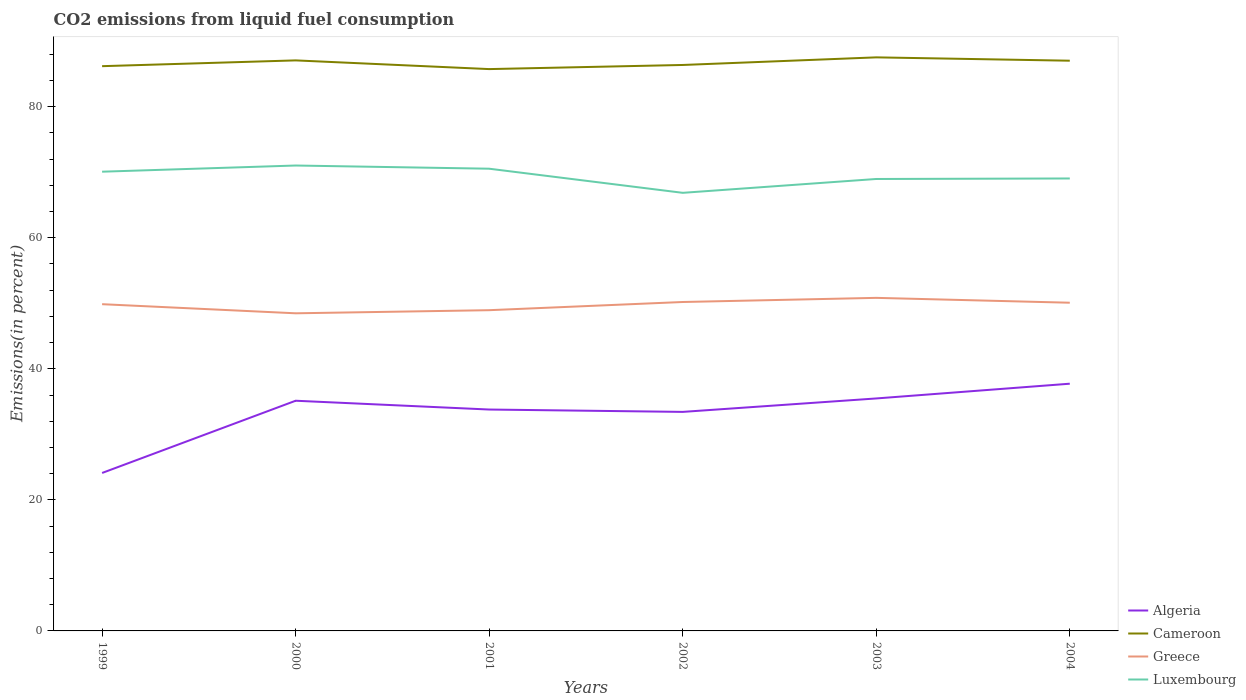How many different coloured lines are there?
Your answer should be very brief. 4. Is the number of lines equal to the number of legend labels?
Provide a succinct answer. Yes. Across all years, what is the maximum total CO2 emitted in Luxembourg?
Give a very brief answer. 66.86. In which year was the total CO2 emitted in Algeria maximum?
Offer a terse response. 1999. What is the total total CO2 emitted in Greece in the graph?
Offer a terse response. -2.36. What is the difference between the highest and the second highest total CO2 emitted in Greece?
Provide a short and direct response. 2.36. What is the difference between the highest and the lowest total CO2 emitted in Cameroon?
Your answer should be very brief. 3. How many years are there in the graph?
Ensure brevity in your answer.  6. What is the difference between two consecutive major ticks on the Y-axis?
Offer a very short reply. 20. Are the values on the major ticks of Y-axis written in scientific E-notation?
Offer a terse response. No. Does the graph contain grids?
Offer a terse response. No. What is the title of the graph?
Ensure brevity in your answer.  CO2 emissions from liquid fuel consumption. What is the label or title of the X-axis?
Keep it short and to the point. Years. What is the label or title of the Y-axis?
Provide a short and direct response. Emissions(in percent). What is the Emissions(in percent) in Algeria in 1999?
Give a very brief answer. 24.11. What is the Emissions(in percent) in Cameroon in 1999?
Make the answer very short. 86.19. What is the Emissions(in percent) of Greece in 1999?
Make the answer very short. 49.86. What is the Emissions(in percent) of Luxembourg in 1999?
Provide a succinct answer. 70.09. What is the Emissions(in percent) in Algeria in 2000?
Your answer should be compact. 35.13. What is the Emissions(in percent) of Cameroon in 2000?
Offer a terse response. 87.07. What is the Emissions(in percent) in Greece in 2000?
Your response must be concise. 48.48. What is the Emissions(in percent) of Luxembourg in 2000?
Make the answer very short. 71.03. What is the Emissions(in percent) in Algeria in 2001?
Keep it short and to the point. 33.79. What is the Emissions(in percent) in Cameroon in 2001?
Make the answer very short. 85.74. What is the Emissions(in percent) in Greece in 2001?
Make the answer very short. 48.95. What is the Emissions(in percent) of Luxembourg in 2001?
Provide a short and direct response. 70.54. What is the Emissions(in percent) in Algeria in 2002?
Keep it short and to the point. 33.43. What is the Emissions(in percent) of Cameroon in 2002?
Your answer should be very brief. 86.37. What is the Emissions(in percent) in Greece in 2002?
Your answer should be very brief. 50.2. What is the Emissions(in percent) of Luxembourg in 2002?
Offer a very short reply. 66.86. What is the Emissions(in percent) in Algeria in 2003?
Offer a terse response. 35.48. What is the Emissions(in percent) in Cameroon in 2003?
Keep it short and to the point. 87.54. What is the Emissions(in percent) in Greece in 2003?
Your answer should be very brief. 50.83. What is the Emissions(in percent) of Luxembourg in 2003?
Offer a very short reply. 68.97. What is the Emissions(in percent) of Algeria in 2004?
Keep it short and to the point. 37.73. What is the Emissions(in percent) of Cameroon in 2004?
Provide a short and direct response. 87.03. What is the Emissions(in percent) of Greece in 2004?
Ensure brevity in your answer.  50.09. What is the Emissions(in percent) of Luxembourg in 2004?
Ensure brevity in your answer.  69.05. Across all years, what is the maximum Emissions(in percent) of Algeria?
Your answer should be very brief. 37.73. Across all years, what is the maximum Emissions(in percent) of Cameroon?
Your answer should be very brief. 87.54. Across all years, what is the maximum Emissions(in percent) of Greece?
Your answer should be compact. 50.83. Across all years, what is the maximum Emissions(in percent) in Luxembourg?
Make the answer very short. 71.03. Across all years, what is the minimum Emissions(in percent) in Algeria?
Your answer should be very brief. 24.11. Across all years, what is the minimum Emissions(in percent) of Cameroon?
Your answer should be compact. 85.74. Across all years, what is the minimum Emissions(in percent) of Greece?
Your answer should be compact. 48.48. Across all years, what is the minimum Emissions(in percent) of Luxembourg?
Offer a very short reply. 66.86. What is the total Emissions(in percent) of Algeria in the graph?
Keep it short and to the point. 199.66. What is the total Emissions(in percent) in Cameroon in the graph?
Your response must be concise. 519.94. What is the total Emissions(in percent) of Greece in the graph?
Offer a very short reply. 298.41. What is the total Emissions(in percent) of Luxembourg in the graph?
Ensure brevity in your answer.  416.54. What is the difference between the Emissions(in percent) in Algeria in 1999 and that in 2000?
Keep it short and to the point. -11.02. What is the difference between the Emissions(in percent) of Cameroon in 1999 and that in 2000?
Your response must be concise. -0.88. What is the difference between the Emissions(in percent) of Greece in 1999 and that in 2000?
Provide a succinct answer. 1.39. What is the difference between the Emissions(in percent) of Luxembourg in 1999 and that in 2000?
Offer a terse response. -0.94. What is the difference between the Emissions(in percent) in Algeria in 1999 and that in 2001?
Give a very brief answer. -9.68. What is the difference between the Emissions(in percent) in Cameroon in 1999 and that in 2001?
Keep it short and to the point. 0.45. What is the difference between the Emissions(in percent) in Greece in 1999 and that in 2001?
Your response must be concise. 0.91. What is the difference between the Emissions(in percent) in Luxembourg in 1999 and that in 2001?
Provide a short and direct response. -0.46. What is the difference between the Emissions(in percent) of Algeria in 1999 and that in 2002?
Offer a very short reply. -9.32. What is the difference between the Emissions(in percent) of Cameroon in 1999 and that in 2002?
Provide a short and direct response. -0.18. What is the difference between the Emissions(in percent) in Greece in 1999 and that in 2002?
Offer a terse response. -0.34. What is the difference between the Emissions(in percent) of Luxembourg in 1999 and that in 2002?
Provide a short and direct response. 3.22. What is the difference between the Emissions(in percent) of Algeria in 1999 and that in 2003?
Provide a succinct answer. -11.37. What is the difference between the Emissions(in percent) of Cameroon in 1999 and that in 2003?
Make the answer very short. -1.35. What is the difference between the Emissions(in percent) of Greece in 1999 and that in 2003?
Provide a succinct answer. -0.97. What is the difference between the Emissions(in percent) in Luxembourg in 1999 and that in 2003?
Provide a succinct answer. 1.11. What is the difference between the Emissions(in percent) of Algeria in 1999 and that in 2004?
Keep it short and to the point. -13.62. What is the difference between the Emissions(in percent) in Cameroon in 1999 and that in 2004?
Make the answer very short. -0.83. What is the difference between the Emissions(in percent) of Greece in 1999 and that in 2004?
Provide a short and direct response. -0.22. What is the difference between the Emissions(in percent) of Luxembourg in 1999 and that in 2004?
Your answer should be very brief. 1.03. What is the difference between the Emissions(in percent) of Algeria in 2000 and that in 2001?
Your response must be concise. 1.34. What is the difference between the Emissions(in percent) in Cameroon in 2000 and that in 2001?
Your answer should be compact. 1.33. What is the difference between the Emissions(in percent) of Greece in 2000 and that in 2001?
Your answer should be compact. -0.48. What is the difference between the Emissions(in percent) in Luxembourg in 2000 and that in 2001?
Keep it short and to the point. 0.49. What is the difference between the Emissions(in percent) of Algeria in 2000 and that in 2002?
Keep it short and to the point. 1.7. What is the difference between the Emissions(in percent) of Cameroon in 2000 and that in 2002?
Provide a short and direct response. 0.7. What is the difference between the Emissions(in percent) of Greece in 2000 and that in 2002?
Provide a succinct answer. -1.72. What is the difference between the Emissions(in percent) in Luxembourg in 2000 and that in 2002?
Ensure brevity in your answer.  4.17. What is the difference between the Emissions(in percent) in Algeria in 2000 and that in 2003?
Keep it short and to the point. -0.35. What is the difference between the Emissions(in percent) of Cameroon in 2000 and that in 2003?
Offer a terse response. -0.46. What is the difference between the Emissions(in percent) in Greece in 2000 and that in 2003?
Ensure brevity in your answer.  -2.36. What is the difference between the Emissions(in percent) in Luxembourg in 2000 and that in 2003?
Your answer should be very brief. 2.05. What is the difference between the Emissions(in percent) in Algeria in 2000 and that in 2004?
Give a very brief answer. -2.6. What is the difference between the Emissions(in percent) of Cameroon in 2000 and that in 2004?
Your answer should be compact. 0.05. What is the difference between the Emissions(in percent) of Greece in 2000 and that in 2004?
Your response must be concise. -1.61. What is the difference between the Emissions(in percent) of Luxembourg in 2000 and that in 2004?
Provide a succinct answer. 1.98. What is the difference between the Emissions(in percent) in Algeria in 2001 and that in 2002?
Keep it short and to the point. 0.36. What is the difference between the Emissions(in percent) of Cameroon in 2001 and that in 2002?
Provide a short and direct response. -0.63. What is the difference between the Emissions(in percent) in Greece in 2001 and that in 2002?
Offer a very short reply. -1.25. What is the difference between the Emissions(in percent) in Luxembourg in 2001 and that in 2002?
Provide a succinct answer. 3.68. What is the difference between the Emissions(in percent) of Algeria in 2001 and that in 2003?
Ensure brevity in your answer.  -1.69. What is the difference between the Emissions(in percent) of Cameroon in 2001 and that in 2003?
Provide a short and direct response. -1.79. What is the difference between the Emissions(in percent) in Greece in 2001 and that in 2003?
Make the answer very short. -1.88. What is the difference between the Emissions(in percent) of Luxembourg in 2001 and that in 2003?
Ensure brevity in your answer.  1.57. What is the difference between the Emissions(in percent) in Algeria in 2001 and that in 2004?
Offer a terse response. -3.94. What is the difference between the Emissions(in percent) in Cameroon in 2001 and that in 2004?
Ensure brevity in your answer.  -1.28. What is the difference between the Emissions(in percent) in Greece in 2001 and that in 2004?
Keep it short and to the point. -1.14. What is the difference between the Emissions(in percent) in Luxembourg in 2001 and that in 2004?
Provide a short and direct response. 1.49. What is the difference between the Emissions(in percent) in Algeria in 2002 and that in 2003?
Ensure brevity in your answer.  -2.05. What is the difference between the Emissions(in percent) of Cameroon in 2002 and that in 2003?
Provide a short and direct response. -1.16. What is the difference between the Emissions(in percent) of Greece in 2002 and that in 2003?
Your response must be concise. -0.63. What is the difference between the Emissions(in percent) of Luxembourg in 2002 and that in 2003?
Your answer should be compact. -2.11. What is the difference between the Emissions(in percent) in Algeria in 2002 and that in 2004?
Offer a terse response. -4.3. What is the difference between the Emissions(in percent) in Cameroon in 2002 and that in 2004?
Keep it short and to the point. -0.65. What is the difference between the Emissions(in percent) of Greece in 2002 and that in 2004?
Offer a terse response. 0.11. What is the difference between the Emissions(in percent) of Luxembourg in 2002 and that in 2004?
Offer a very short reply. -2.19. What is the difference between the Emissions(in percent) of Algeria in 2003 and that in 2004?
Offer a terse response. -2.25. What is the difference between the Emissions(in percent) of Cameroon in 2003 and that in 2004?
Your response must be concise. 0.51. What is the difference between the Emissions(in percent) in Greece in 2003 and that in 2004?
Offer a very short reply. 0.74. What is the difference between the Emissions(in percent) in Luxembourg in 2003 and that in 2004?
Your answer should be very brief. -0.08. What is the difference between the Emissions(in percent) in Algeria in 1999 and the Emissions(in percent) in Cameroon in 2000?
Keep it short and to the point. -62.97. What is the difference between the Emissions(in percent) of Algeria in 1999 and the Emissions(in percent) of Greece in 2000?
Your answer should be compact. -24.37. What is the difference between the Emissions(in percent) in Algeria in 1999 and the Emissions(in percent) in Luxembourg in 2000?
Your response must be concise. -46.92. What is the difference between the Emissions(in percent) in Cameroon in 1999 and the Emissions(in percent) in Greece in 2000?
Keep it short and to the point. 37.72. What is the difference between the Emissions(in percent) in Cameroon in 1999 and the Emissions(in percent) in Luxembourg in 2000?
Your answer should be very brief. 15.16. What is the difference between the Emissions(in percent) in Greece in 1999 and the Emissions(in percent) in Luxembourg in 2000?
Provide a short and direct response. -21.16. What is the difference between the Emissions(in percent) in Algeria in 1999 and the Emissions(in percent) in Cameroon in 2001?
Your response must be concise. -61.64. What is the difference between the Emissions(in percent) in Algeria in 1999 and the Emissions(in percent) in Greece in 2001?
Offer a very short reply. -24.84. What is the difference between the Emissions(in percent) of Algeria in 1999 and the Emissions(in percent) of Luxembourg in 2001?
Provide a succinct answer. -46.43. What is the difference between the Emissions(in percent) in Cameroon in 1999 and the Emissions(in percent) in Greece in 2001?
Offer a very short reply. 37.24. What is the difference between the Emissions(in percent) of Cameroon in 1999 and the Emissions(in percent) of Luxembourg in 2001?
Offer a very short reply. 15.65. What is the difference between the Emissions(in percent) in Greece in 1999 and the Emissions(in percent) in Luxembourg in 2001?
Your answer should be very brief. -20.68. What is the difference between the Emissions(in percent) of Algeria in 1999 and the Emissions(in percent) of Cameroon in 2002?
Provide a short and direct response. -62.27. What is the difference between the Emissions(in percent) of Algeria in 1999 and the Emissions(in percent) of Greece in 2002?
Ensure brevity in your answer.  -26.09. What is the difference between the Emissions(in percent) of Algeria in 1999 and the Emissions(in percent) of Luxembourg in 2002?
Ensure brevity in your answer.  -42.75. What is the difference between the Emissions(in percent) in Cameroon in 1999 and the Emissions(in percent) in Greece in 2002?
Offer a terse response. 35.99. What is the difference between the Emissions(in percent) of Cameroon in 1999 and the Emissions(in percent) of Luxembourg in 2002?
Offer a terse response. 19.33. What is the difference between the Emissions(in percent) in Greece in 1999 and the Emissions(in percent) in Luxembourg in 2002?
Provide a succinct answer. -17. What is the difference between the Emissions(in percent) of Algeria in 1999 and the Emissions(in percent) of Cameroon in 2003?
Your answer should be very brief. -63.43. What is the difference between the Emissions(in percent) of Algeria in 1999 and the Emissions(in percent) of Greece in 2003?
Provide a short and direct response. -26.72. What is the difference between the Emissions(in percent) in Algeria in 1999 and the Emissions(in percent) in Luxembourg in 2003?
Keep it short and to the point. -44.87. What is the difference between the Emissions(in percent) in Cameroon in 1999 and the Emissions(in percent) in Greece in 2003?
Your answer should be compact. 35.36. What is the difference between the Emissions(in percent) in Cameroon in 1999 and the Emissions(in percent) in Luxembourg in 2003?
Offer a very short reply. 17.22. What is the difference between the Emissions(in percent) of Greece in 1999 and the Emissions(in percent) of Luxembourg in 2003?
Your answer should be compact. -19.11. What is the difference between the Emissions(in percent) of Algeria in 1999 and the Emissions(in percent) of Cameroon in 2004?
Ensure brevity in your answer.  -62.92. What is the difference between the Emissions(in percent) of Algeria in 1999 and the Emissions(in percent) of Greece in 2004?
Your answer should be compact. -25.98. What is the difference between the Emissions(in percent) of Algeria in 1999 and the Emissions(in percent) of Luxembourg in 2004?
Ensure brevity in your answer.  -44.95. What is the difference between the Emissions(in percent) of Cameroon in 1999 and the Emissions(in percent) of Greece in 2004?
Your answer should be very brief. 36.1. What is the difference between the Emissions(in percent) of Cameroon in 1999 and the Emissions(in percent) of Luxembourg in 2004?
Ensure brevity in your answer.  17.14. What is the difference between the Emissions(in percent) in Greece in 1999 and the Emissions(in percent) in Luxembourg in 2004?
Ensure brevity in your answer.  -19.19. What is the difference between the Emissions(in percent) of Algeria in 2000 and the Emissions(in percent) of Cameroon in 2001?
Make the answer very short. -50.61. What is the difference between the Emissions(in percent) of Algeria in 2000 and the Emissions(in percent) of Greece in 2001?
Your answer should be very brief. -13.82. What is the difference between the Emissions(in percent) of Algeria in 2000 and the Emissions(in percent) of Luxembourg in 2001?
Offer a terse response. -35.41. What is the difference between the Emissions(in percent) in Cameroon in 2000 and the Emissions(in percent) in Greece in 2001?
Ensure brevity in your answer.  38.12. What is the difference between the Emissions(in percent) of Cameroon in 2000 and the Emissions(in percent) of Luxembourg in 2001?
Your answer should be very brief. 16.53. What is the difference between the Emissions(in percent) of Greece in 2000 and the Emissions(in percent) of Luxembourg in 2001?
Provide a succinct answer. -22.07. What is the difference between the Emissions(in percent) of Algeria in 2000 and the Emissions(in percent) of Cameroon in 2002?
Provide a succinct answer. -51.24. What is the difference between the Emissions(in percent) in Algeria in 2000 and the Emissions(in percent) in Greece in 2002?
Give a very brief answer. -15.07. What is the difference between the Emissions(in percent) of Algeria in 2000 and the Emissions(in percent) of Luxembourg in 2002?
Ensure brevity in your answer.  -31.73. What is the difference between the Emissions(in percent) of Cameroon in 2000 and the Emissions(in percent) of Greece in 2002?
Your answer should be very brief. 36.87. What is the difference between the Emissions(in percent) of Cameroon in 2000 and the Emissions(in percent) of Luxembourg in 2002?
Give a very brief answer. 20.21. What is the difference between the Emissions(in percent) in Greece in 2000 and the Emissions(in percent) in Luxembourg in 2002?
Provide a short and direct response. -18.39. What is the difference between the Emissions(in percent) in Algeria in 2000 and the Emissions(in percent) in Cameroon in 2003?
Offer a very short reply. -52.41. What is the difference between the Emissions(in percent) in Algeria in 2000 and the Emissions(in percent) in Greece in 2003?
Your answer should be very brief. -15.7. What is the difference between the Emissions(in percent) in Algeria in 2000 and the Emissions(in percent) in Luxembourg in 2003?
Give a very brief answer. -33.84. What is the difference between the Emissions(in percent) in Cameroon in 2000 and the Emissions(in percent) in Greece in 2003?
Provide a short and direct response. 36.24. What is the difference between the Emissions(in percent) in Cameroon in 2000 and the Emissions(in percent) in Luxembourg in 2003?
Give a very brief answer. 18.1. What is the difference between the Emissions(in percent) in Greece in 2000 and the Emissions(in percent) in Luxembourg in 2003?
Provide a short and direct response. -20.5. What is the difference between the Emissions(in percent) in Algeria in 2000 and the Emissions(in percent) in Cameroon in 2004?
Your answer should be very brief. -51.89. What is the difference between the Emissions(in percent) in Algeria in 2000 and the Emissions(in percent) in Greece in 2004?
Your response must be concise. -14.96. What is the difference between the Emissions(in percent) in Algeria in 2000 and the Emissions(in percent) in Luxembourg in 2004?
Your response must be concise. -33.92. What is the difference between the Emissions(in percent) in Cameroon in 2000 and the Emissions(in percent) in Greece in 2004?
Provide a succinct answer. 36.98. What is the difference between the Emissions(in percent) in Cameroon in 2000 and the Emissions(in percent) in Luxembourg in 2004?
Your response must be concise. 18.02. What is the difference between the Emissions(in percent) in Greece in 2000 and the Emissions(in percent) in Luxembourg in 2004?
Your answer should be very brief. -20.58. What is the difference between the Emissions(in percent) of Algeria in 2001 and the Emissions(in percent) of Cameroon in 2002?
Ensure brevity in your answer.  -52.58. What is the difference between the Emissions(in percent) of Algeria in 2001 and the Emissions(in percent) of Greece in 2002?
Offer a very short reply. -16.41. What is the difference between the Emissions(in percent) of Algeria in 2001 and the Emissions(in percent) of Luxembourg in 2002?
Give a very brief answer. -33.07. What is the difference between the Emissions(in percent) of Cameroon in 2001 and the Emissions(in percent) of Greece in 2002?
Your answer should be very brief. 35.55. What is the difference between the Emissions(in percent) of Cameroon in 2001 and the Emissions(in percent) of Luxembourg in 2002?
Give a very brief answer. 18.88. What is the difference between the Emissions(in percent) in Greece in 2001 and the Emissions(in percent) in Luxembourg in 2002?
Provide a short and direct response. -17.91. What is the difference between the Emissions(in percent) in Algeria in 2001 and the Emissions(in percent) in Cameroon in 2003?
Ensure brevity in your answer.  -53.75. What is the difference between the Emissions(in percent) in Algeria in 2001 and the Emissions(in percent) in Greece in 2003?
Provide a short and direct response. -17.04. What is the difference between the Emissions(in percent) of Algeria in 2001 and the Emissions(in percent) of Luxembourg in 2003?
Ensure brevity in your answer.  -35.19. What is the difference between the Emissions(in percent) of Cameroon in 2001 and the Emissions(in percent) of Greece in 2003?
Ensure brevity in your answer.  34.91. What is the difference between the Emissions(in percent) of Cameroon in 2001 and the Emissions(in percent) of Luxembourg in 2003?
Your response must be concise. 16.77. What is the difference between the Emissions(in percent) in Greece in 2001 and the Emissions(in percent) in Luxembourg in 2003?
Keep it short and to the point. -20.02. What is the difference between the Emissions(in percent) in Algeria in 2001 and the Emissions(in percent) in Cameroon in 2004?
Keep it short and to the point. -53.24. What is the difference between the Emissions(in percent) of Algeria in 2001 and the Emissions(in percent) of Greece in 2004?
Keep it short and to the point. -16.3. What is the difference between the Emissions(in percent) of Algeria in 2001 and the Emissions(in percent) of Luxembourg in 2004?
Your answer should be very brief. -35.26. What is the difference between the Emissions(in percent) in Cameroon in 2001 and the Emissions(in percent) in Greece in 2004?
Provide a short and direct response. 35.66. What is the difference between the Emissions(in percent) in Cameroon in 2001 and the Emissions(in percent) in Luxembourg in 2004?
Provide a short and direct response. 16.69. What is the difference between the Emissions(in percent) in Greece in 2001 and the Emissions(in percent) in Luxembourg in 2004?
Your answer should be very brief. -20.1. What is the difference between the Emissions(in percent) in Algeria in 2002 and the Emissions(in percent) in Cameroon in 2003?
Provide a short and direct response. -54.11. What is the difference between the Emissions(in percent) in Algeria in 2002 and the Emissions(in percent) in Greece in 2003?
Keep it short and to the point. -17.4. What is the difference between the Emissions(in percent) of Algeria in 2002 and the Emissions(in percent) of Luxembourg in 2003?
Offer a very short reply. -35.55. What is the difference between the Emissions(in percent) of Cameroon in 2002 and the Emissions(in percent) of Greece in 2003?
Your answer should be very brief. 35.54. What is the difference between the Emissions(in percent) of Cameroon in 2002 and the Emissions(in percent) of Luxembourg in 2003?
Keep it short and to the point. 17.4. What is the difference between the Emissions(in percent) in Greece in 2002 and the Emissions(in percent) in Luxembourg in 2003?
Provide a succinct answer. -18.77. What is the difference between the Emissions(in percent) of Algeria in 2002 and the Emissions(in percent) of Cameroon in 2004?
Your answer should be very brief. -53.6. What is the difference between the Emissions(in percent) in Algeria in 2002 and the Emissions(in percent) in Greece in 2004?
Your answer should be very brief. -16.66. What is the difference between the Emissions(in percent) in Algeria in 2002 and the Emissions(in percent) in Luxembourg in 2004?
Your answer should be very brief. -35.63. What is the difference between the Emissions(in percent) of Cameroon in 2002 and the Emissions(in percent) of Greece in 2004?
Make the answer very short. 36.28. What is the difference between the Emissions(in percent) of Cameroon in 2002 and the Emissions(in percent) of Luxembourg in 2004?
Offer a very short reply. 17.32. What is the difference between the Emissions(in percent) in Greece in 2002 and the Emissions(in percent) in Luxembourg in 2004?
Your answer should be very brief. -18.85. What is the difference between the Emissions(in percent) of Algeria in 2003 and the Emissions(in percent) of Cameroon in 2004?
Give a very brief answer. -51.55. What is the difference between the Emissions(in percent) of Algeria in 2003 and the Emissions(in percent) of Greece in 2004?
Give a very brief answer. -14.61. What is the difference between the Emissions(in percent) in Algeria in 2003 and the Emissions(in percent) in Luxembourg in 2004?
Your response must be concise. -33.57. What is the difference between the Emissions(in percent) of Cameroon in 2003 and the Emissions(in percent) of Greece in 2004?
Provide a succinct answer. 37.45. What is the difference between the Emissions(in percent) in Cameroon in 2003 and the Emissions(in percent) in Luxembourg in 2004?
Ensure brevity in your answer.  18.48. What is the difference between the Emissions(in percent) in Greece in 2003 and the Emissions(in percent) in Luxembourg in 2004?
Your answer should be compact. -18.22. What is the average Emissions(in percent) of Algeria per year?
Give a very brief answer. 33.28. What is the average Emissions(in percent) of Cameroon per year?
Provide a succinct answer. 86.66. What is the average Emissions(in percent) in Greece per year?
Provide a short and direct response. 49.73. What is the average Emissions(in percent) in Luxembourg per year?
Your answer should be very brief. 69.42. In the year 1999, what is the difference between the Emissions(in percent) in Algeria and Emissions(in percent) in Cameroon?
Your answer should be very brief. -62.08. In the year 1999, what is the difference between the Emissions(in percent) in Algeria and Emissions(in percent) in Greece?
Give a very brief answer. -25.76. In the year 1999, what is the difference between the Emissions(in percent) of Algeria and Emissions(in percent) of Luxembourg?
Keep it short and to the point. -45.98. In the year 1999, what is the difference between the Emissions(in percent) of Cameroon and Emissions(in percent) of Greece?
Your answer should be compact. 36.33. In the year 1999, what is the difference between the Emissions(in percent) in Cameroon and Emissions(in percent) in Luxembourg?
Make the answer very short. 16.1. In the year 1999, what is the difference between the Emissions(in percent) of Greece and Emissions(in percent) of Luxembourg?
Ensure brevity in your answer.  -20.22. In the year 2000, what is the difference between the Emissions(in percent) of Algeria and Emissions(in percent) of Cameroon?
Your response must be concise. -51.94. In the year 2000, what is the difference between the Emissions(in percent) of Algeria and Emissions(in percent) of Greece?
Give a very brief answer. -13.34. In the year 2000, what is the difference between the Emissions(in percent) of Algeria and Emissions(in percent) of Luxembourg?
Your answer should be compact. -35.9. In the year 2000, what is the difference between the Emissions(in percent) of Cameroon and Emissions(in percent) of Greece?
Offer a very short reply. 38.6. In the year 2000, what is the difference between the Emissions(in percent) of Cameroon and Emissions(in percent) of Luxembourg?
Offer a terse response. 16.04. In the year 2000, what is the difference between the Emissions(in percent) of Greece and Emissions(in percent) of Luxembourg?
Your answer should be very brief. -22.55. In the year 2001, what is the difference between the Emissions(in percent) of Algeria and Emissions(in percent) of Cameroon?
Give a very brief answer. -51.96. In the year 2001, what is the difference between the Emissions(in percent) in Algeria and Emissions(in percent) in Greece?
Keep it short and to the point. -15.16. In the year 2001, what is the difference between the Emissions(in percent) in Algeria and Emissions(in percent) in Luxembourg?
Ensure brevity in your answer.  -36.75. In the year 2001, what is the difference between the Emissions(in percent) in Cameroon and Emissions(in percent) in Greece?
Keep it short and to the point. 36.79. In the year 2001, what is the difference between the Emissions(in percent) of Cameroon and Emissions(in percent) of Luxembourg?
Keep it short and to the point. 15.2. In the year 2001, what is the difference between the Emissions(in percent) of Greece and Emissions(in percent) of Luxembourg?
Make the answer very short. -21.59. In the year 2002, what is the difference between the Emissions(in percent) of Algeria and Emissions(in percent) of Cameroon?
Keep it short and to the point. -52.95. In the year 2002, what is the difference between the Emissions(in percent) in Algeria and Emissions(in percent) in Greece?
Your answer should be very brief. -16.77. In the year 2002, what is the difference between the Emissions(in percent) in Algeria and Emissions(in percent) in Luxembourg?
Provide a succinct answer. -33.43. In the year 2002, what is the difference between the Emissions(in percent) of Cameroon and Emissions(in percent) of Greece?
Make the answer very short. 36.17. In the year 2002, what is the difference between the Emissions(in percent) in Cameroon and Emissions(in percent) in Luxembourg?
Offer a terse response. 19.51. In the year 2002, what is the difference between the Emissions(in percent) in Greece and Emissions(in percent) in Luxembourg?
Provide a succinct answer. -16.66. In the year 2003, what is the difference between the Emissions(in percent) of Algeria and Emissions(in percent) of Cameroon?
Your answer should be very brief. -52.06. In the year 2003, what is the difference between the Emissions(in percent) of Algeria and Emissions(in percent) of Greece?
Offer a very short reply. -15.35. In the year 2003, what is the difference between the Emissions(in percent) of Algeria and Emissions(in percent) of Luxembourg?
Offer a terse response. -33.49. In the year 2003, what is the difference between the Emissions(in percent) of Cameroon and Emissions(in percent) of Greece?
Keep it short and to the point. 36.71. In the year 2003, what is the difference between the Emissions(in percent) of Cameroon and Emissions(in percent) of Luxembourg?
Your response must be concise. 18.56. In the year 2003, what is the difference between the Emissions(in percent) in Greece and Emissions(in percent) in Luxembourg?
Offer a terse response. -18.14. In the year 2004, what is the difference between the Emissions(in percent) in Algeria and Emissions(in percent) in Cameroon?
Make the answer very short. -49.3. In the year 2004, what is the difference between the Emissions(in percent) of Algeria and Emissions(in percent) of Greece?
Your answer should be very brief. -12.36. In the year 2004, what is the difference between the Emissions(in percent) of Algeria and Emissions(in percent) of Luxembourg?
Keep it short and to the point. -31.32. In the year 2004, what is the difference between the Emissions(in percent) of Cameroon and Emissions(in percent) of Greece?
Your answer should be compact. 36.94. In the year 2004, what is the difference between the Emissions(in percent) in Cameroon and Emissions(in percent) in Luxembourg?
Your response must be concise. 17.97. In the year 2004, what is the difference between the Emissions(in percent) of Greece and Emissions(in percent) of Luxembourg?
Your answer should be compact. -18.96. What is the ratio of the Emissions(in percent) of Algeria in 1999 to that in 2000?
Offer a terse response. 0.69. What is the ratio of the Emissions(in percent) of Cameroon in 1999 to that in 2000?
Your answer should be compact. 0.99. What is the ratio of the Emissions(in percent) of Greece in 1999 to that in 2000?
Your response must be concise. 1.03. What is the ratio of the Emissions(in percent) in Luxembourg in 1999 to that in 2000?
Your response must be concise. 0.99. What is the ratio of the Emissions(in percent) in Algeria in 1999 to that in 2001?
Give a very brief answer. 0.71. What is the ratio of the Emissions(in percent) of Greece in 1999 to that in 2001?
Keep it short and to the point. 1.02. What is the ratio of the Emissions(in percent) in Algeria in 1999 to that in 2002?
Make the answer very short. 0.72. What is the ratio of the Emissions(in percent) of Cameroon in 1999 to that in 2002?
Your answer should be compact. 1. What is the ratio of the Emissions(in percent) of Luxembourg in 1999 to that in 2002?
Provide a succinct answer. 1.05. What is the ratio of the Emissions(in percent) of Algeria in 1999 to that in 2003?
Make the answer very short. 0.68. What is the ratio of the Emissions(in percent) of Cameroon in 1999 to that in 2003?
Your response must be concise. 0.98. What is the ratio of the Emissions(in percent) of Greece in 1999 to that in 2003?
Provide a short and direct response. 0.98. What is the ratio of the Emissions(in percent) in Luxembourg in 1999 to that in 2003?
Provide a short and direct response. 1.02. What is the ratio of the Emissions(in percent) of Algeria in 1999 to that in 2004?
Your response must be concise. 0.64. What is the ratio of the Emissions(in percent) in Greece in 1999 to that in 2004?
Make the answer very short. 1. What is the ratio of the Emissions(in percent) in Algeria in 2000 to that in 2001?
Your answer should be very brief. 1.04. What is the ratio of the Emissions(in percent) in Cameroon in 2000 to that in 2001?
Your answer should be compact. 1.02. What is the ratio of the Emissions(in percent) of Greece in 2000 to that in 2001?
Your response must be concise. 0.99. What is the ratio of the Emissions(in percent) of Algeria in 2000 to that in 2002?
Keep it short and to the point. 1.05. What is the ratio of the Emissions(in percent) in Greece in 2000 to that in 2002?
Provide a short and direct response. 0.97. What is the ratio of the Emissions(in percent) of Luxembourg in 2000 to that in 2002?
Provide a succinct answer. 1.06. What is the ratio of the Emissions(in percent) in Algeria in 2000 to that in 2003?
Your answer should be very brief. 0.99. What is the ratio of the Emissions(in percent) of Greece in 2000 to that in 2003?
Offer a terse response. 0.95. What is the ratio of the Emissions(in percent) of Luxembourg in 2000 to that in 2003?
Your answer should be very brief. 1.03. What is the ratio of the Emissions(in percent) of Algeria in 2000 to that in 2004?
Make the answer very short. 0.93. What is the ratio of the Emissions(in percent) in Greece in 2000 to that in 2004?
Offer a terse response. 0.97. What is the ratio of the Emissions(in percent) of Luxembourg in 2000 to that in 2004?
Offer a terse response. 1.03. What is the ratio of the Emissions(in percent) of Algeria in 2001 to that in 2002?
Your answer should be compact. 1.01. What is the ratio of the Emissions(in percent) of Greece in 2001 to that in 2002?
Make the answer very short. 0.98. What is the ratio of the Emissions(in percent) of Luxembourg in 2001 to that in 2002?
Ensure brevity in your answer.  1.05. What is the ratio of the Emissions(in percent) of Algeria in 2001 to that in 2003?
Offer a terse response. 0.95. What is the ratio of the Emissions(in percent) in Cameroon in 2001 to that in 2003?
Offer a terse response. 0.98. What is the ratio of the Emissions(in percent) of Greece in 2001 to that in 2003?
Provide a succinct answer. 0.96. What is the ratio of the Emissions(in percent) in Luxembourg in 2001 to that in 2003?
Give a very brief answer. 1.02. What is the ratio of the Emissions(in percent) in Algeria in 2001 to that in 2004?
Your answer should be compact. 0.9. What is the ratio of the Emissions(in percent) of Greece in 2001 to that in 2004?
Offer a terse response. 0.98. What is the ratio of the Emissions(in percent) in Luxembourg in 2001 to that in 2004?
Ensure brevity in your answer.  1.02. What is the ratio of the Emissions(in percent) in Algeria in 2002 to that in 2003?
Your answer should be compact. 0.94. What is the ratio of the Emissions(in percent) of Cameroon in 2002 to that in 2003?
Provide a succinct answer. 0.99. What is the ratio of the Emissions(in percent) of Greece in 2002 to that in 2003?
Give a very brief answer. 0.99. What is the ratio of the Emissions(in percent) in Luxembourg in 2002 to that in 2003?
Provide a short and direct response. 0.97. What is the ratio of the Emissions(in percent) in Algeria in 2002 to that in 2004?
Your response must be concise. 0.89. What is the ratio of the Emissions(in percent) of Greece in 2002 to that in 2004?
Offer a very short reply. 1. What is the ratio of the Emissions(in percent) in Luxembourg in 2002 to that in 2004?
Provide a succinct answer. 0.97. What is the ratio of the Emissions(in percent) in Algeria in 2003 to that in 2004?
Give a very brief answer. 0.94. What is the ratio of the Emissions(in percent) of Cameroon in 2003 to that in 2004?
Your answer should be compact. 1.01. What is the ratio of the Emissions(in percent) in Greece in 2003 to that in 2004?
Keep it short and to the point. 1.01. What is the ratio of the Emissions(in percent) in Luxembourg in 2003 to that in 2004?
Your answer should be very brief. 1. What is the difference between the highest and the second highest Emissions(in percent) of Algeria?
Your answer should be compact. 2.25. What is the difference between the highest and the second highest Emissions(in percent) in Cameroon?
Ensure brevity in your answer.  0.46. What is the difference between the highest and the second highest Emissions(in percent) of Greece?
Your answer should be very brief. 0.63. What is the difference between the highest and the second highest Emissions(in percent) in Luxembourg?
Your answer should be compact. 0.49. What is the difference between the highest and the lowest Emissions(in percent) of Algeria?
Ensure brevity in your answer.  13.62. What is the difference between the highest and the lowest Emissions(in percent) of Cameroon?
Give a very brief answer. 1.79. What is the difference between the highest and the lowest Emissions(in percent) in Greece?
Provide a short and direct response. 2.36. What is the difference between the highest and the lowest Emissions(in percent) in Luxembourg?
Keep it short and to the point. 4.17. 